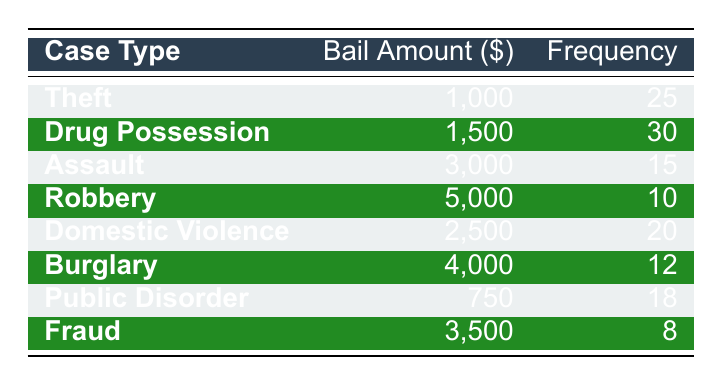What is the bail amount for theft cases? Looking at the "Theft" row in the table, the bail amount is stated as 1,000.
Answer: 1,000 How many cases of drug possession are there? The frequency for "Drug Possession" is provided in the table, which shows a frequency of 30.
Answer: 30 Is the bail amount for robbery higher than that for domestic violence? The bail amount for "Robbery" is 5,000, and for "Domestic Violence" it is 2,500. Since 5,000 is greater than 2,500, the statement is true.
Answer: Yes What is the total frequency of all cases listed? To find the total frequency, sum the frequencies of all cases: 25 + 30 + 15 + 10 + 20 + 12 + 18 + 8 = 138.
Answer: 138 What is the average bail amount for all cases? First, identify the bail amounts: 1,000, 1,500, 3,000, 5,000, 2,500, 4,000, 750, and 3,500, which totals to 21,250. Then count the cases (8) and divide: 21,250 / 8 = 2,656.25.
Answer: 2,656.25 Does the frequency for fraud cases exceed that for burglary cases? The frequency for "Fraud" is 8, while for "Burglary" it is 12. Since 8 is less than 12, the statement is false.
Answer: No Which case type has the highest frequency? Comparing the frequencies, "Drug Possession" has the highest frequency at 30.
Answer: Drug Possession What is the difference in bail amounts between domestic violence and assault cases? The bail amount for "Domestic Violence" is 2,500 and for "Assault" is 3,000. The difference is calculated as 3,000 - 2,500 = 500.
Answer: 500 What case type has the least frequency? Looking through the frequencies, "Fraud" has the lowest frequency of 8.
Answer: Fraud 